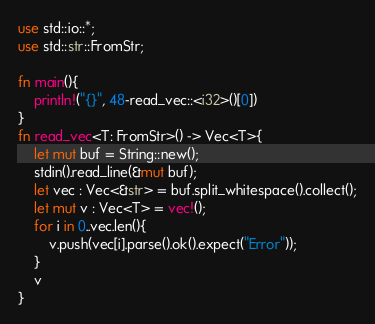<code> <loc_0><loc_0><loc_500><loc_500><_Rust_>use std::io::*;
use std::str::FromStr;

fn main(){
    println!("{}", 48-read_vec::<i32>()[0])
}
fn read_vec<T: FromStr>() -> Vec<T>{
    let mut buf = String::new();
    stdin().read_line(&mut buf);
    let vec : Vec<&str> = buf.split_whitespace().collect();
    let mut v : Vec<T> = vec!();
    for i in 0..vec.len(){
        v.push(vec[i].parse().ok().expect("Error"));
    }
    v
}</code> 